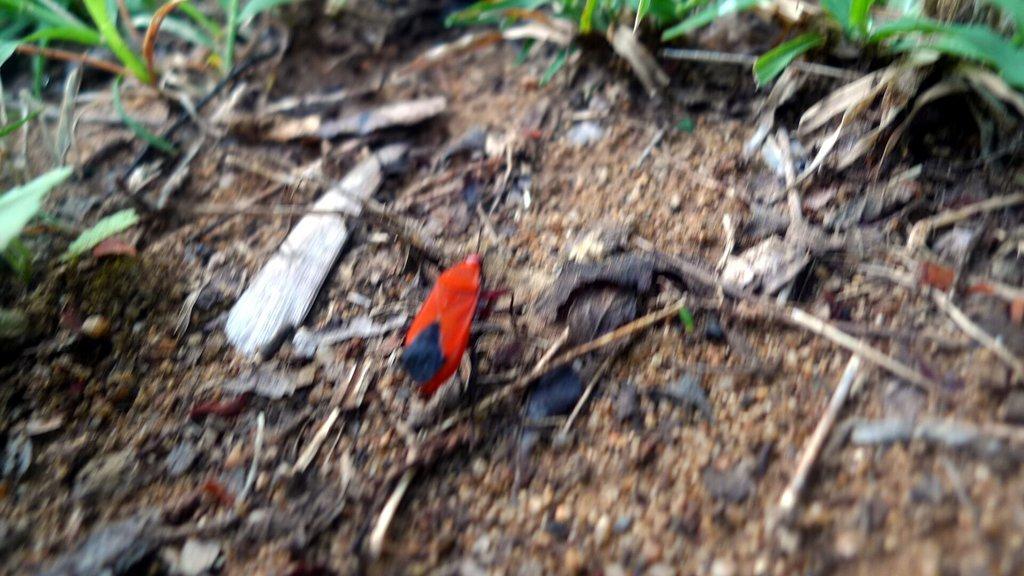How would you summarize this image in a sentence or two? In this image we can see grass, insect and wooden pieces on the ground. 